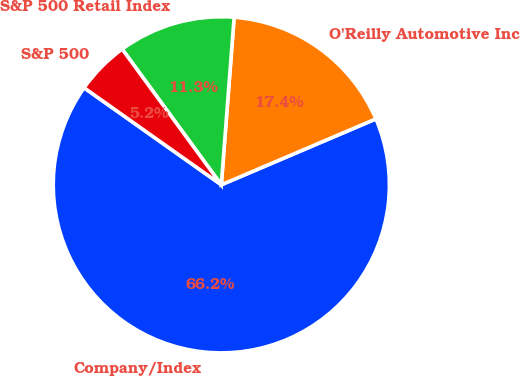Convert chart. <chart><loc_0><loc_0><loc_500><loc_500><pie_chart><fcel>Company/Index<fcel>O'Reilly Automotive Inc<fcel>S&P 500 Retail Index<fcel>S&P 500<nl><fcel>66.21%<fcel>17.37%<fcel>11.26%<fcel>5.16%<nl></chart> 